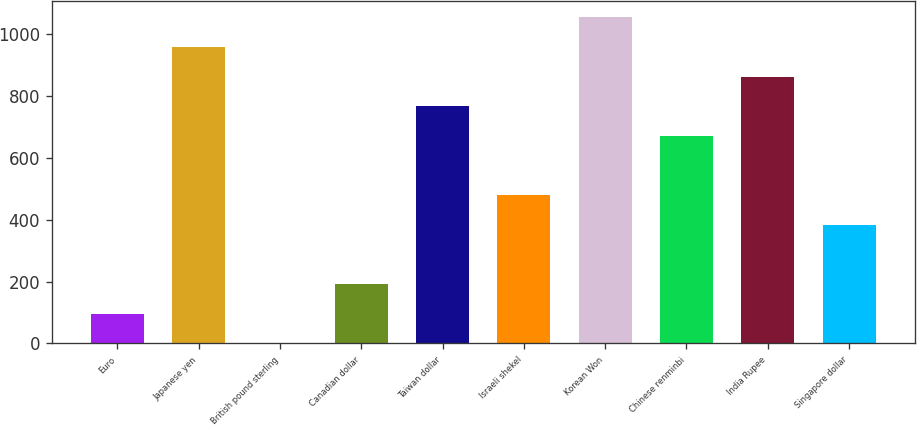Convert chart. <chart><loc_0><loc_0><loc_500><loc_500><bar_chart><fcel>Euro<fcel>Japanese yen<fcel>British pound sterling<fcel>Canadian dollar<fcel>Taiwan dollar<fcel>Israeli shekel<fcel>Korean Won<fcel>Chinese renminbi<fcel>India Rupee<fcel>Singapore dollar<nl><fcel>96.33<fcel>958.53<fcel>0.53<fcel>192.13<fcel>766.93<fcel>479.53<fcel>1054.33<fcel>671.13<fcel>862.73<fcel>383.73<nl></chart> 